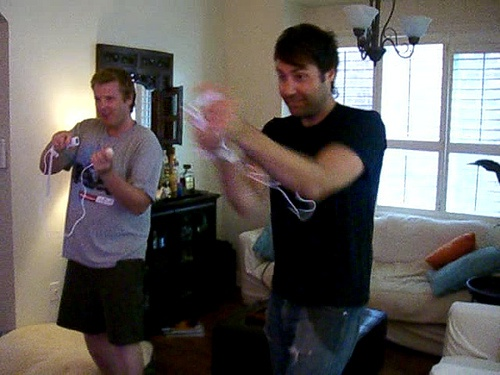Describe the objects in this image and their specific colors. I can see people in gray, black, and maroon tones, people in gray, black, and maroon tones, couch in gray, black, maroon, and blue tones, chair in gray tones, and remote in gray and darkgray tones in this image. 